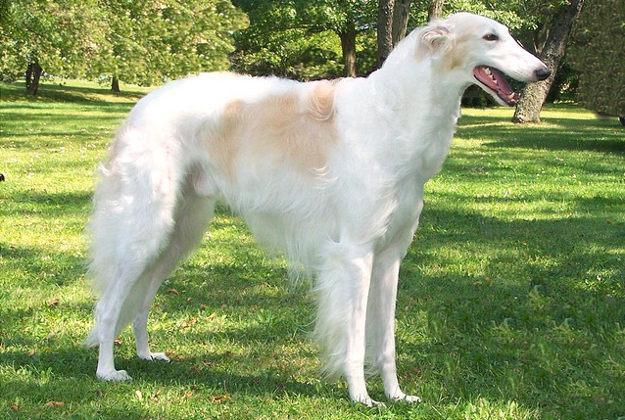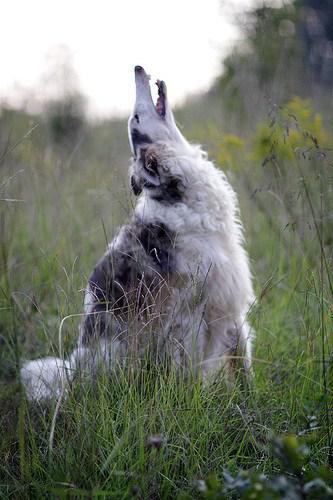The first image is the image on the left, the second image is the image on the right. For the images displayed, is the sentence "The dog in the left image is facing towards the left." factually correct? Answer yes or no. No. The first image is the image on the left, the second image is the image on the right. Analyze the images presented: Is the assertion "Each image contains exactly one long-haired hound standing outdoors on all fours." valid? Answer yes or no. No. 